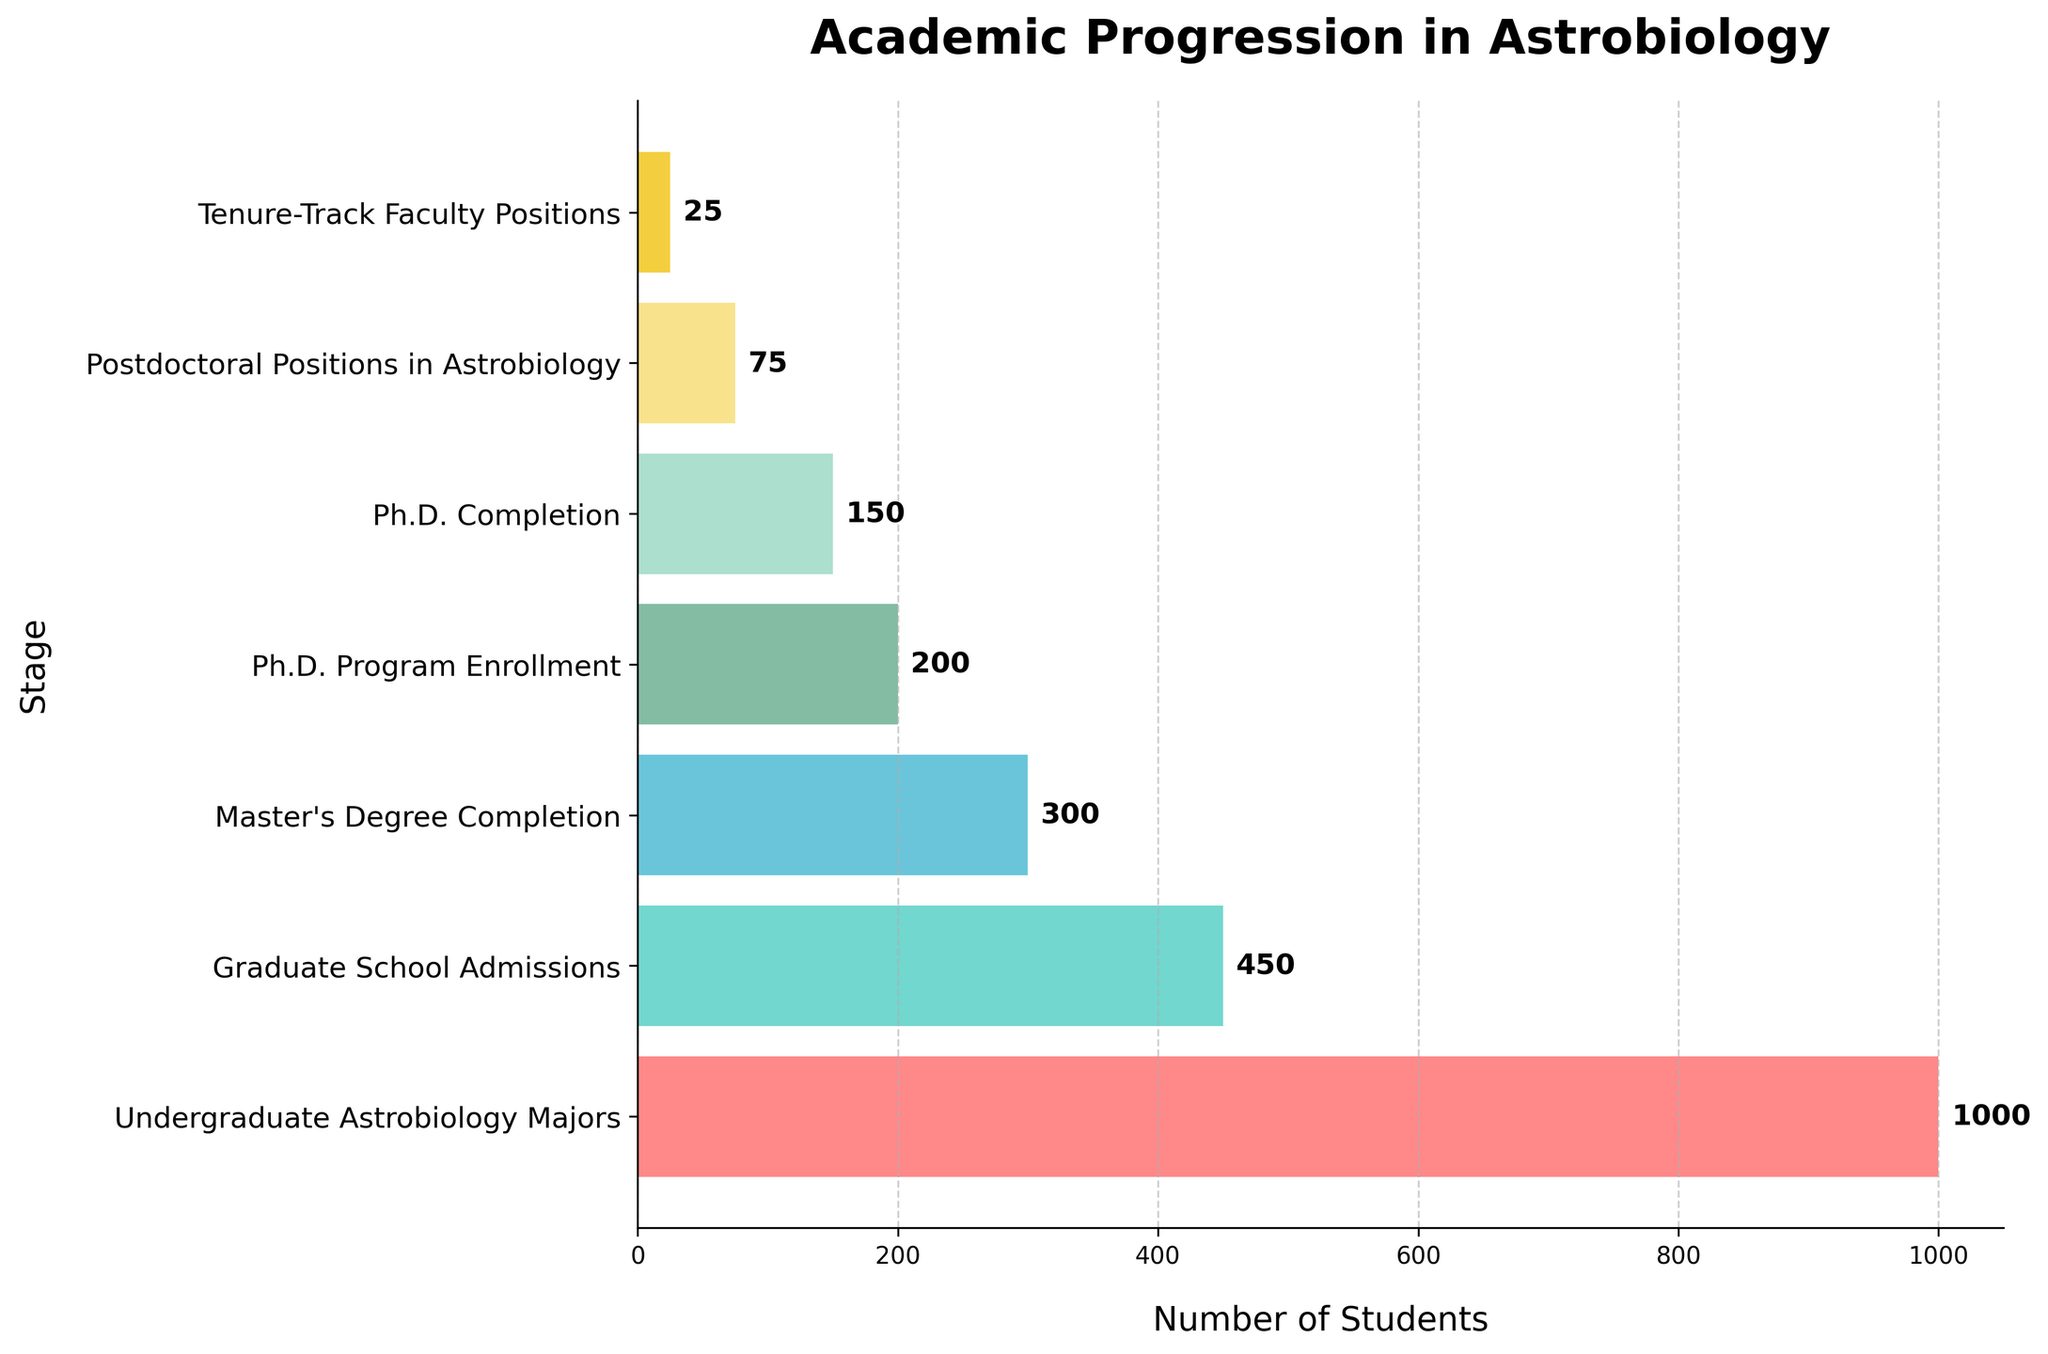What is the title of this chart? The title of the chart is typically placed at the top. In this case, it reads "Academic Progression in Astrobiology".
Answer: Academic Progression in Astrobiology How many stages are represented in this funnel chart? The funnel chart has labels for each stage on the y-axis. By counting these labels, we can see that there are seven stages.
Answer: Seven Which stage has the highest number of students? By looking at the width of the bars on the funnel chart, the widest bar represents the stage with the highest number of students. The label for the widest bar is "Undergraduate Astrobiology Majors".
Answer: Undergraduate Astrobiology Majors What is the number of students who complete their Ph.D. in Astrobiology? We can identify the width of the bar labeled "Ph.D. Completion" on the y-axis, and the number indicated is 150.
Answer: 150 How many students transition from Master's Degree Completion to Ph.D. Program Enrollment? To find the number of students transitioning between these stages, we look at the difference between "Master's Degree Completion" and "Ph.D. Program Enrollment". "Master's Degree Completion" has 300 students and "Ph.D. Program Enrollment" has 200 students. Subtracting these gives the number of students transitioning as 300 - 200 = 100.
Answer: 100 How many more students are admitted to graduate school than those who eventually secure tenure-track faculty positions? The number of students admitted to graduate school is 450, and the number of tenure-track faculty positions is 25. The difference, 450 - 25, gives us 425.
Answer: 425 What percentage of students who begin as undergraduate astrobiology majors eventually complete a Ph.D.? Starting with 1000 undergraduate majors and noting that 150 complete a Ph.D., the percentage is calculated as (150 / 1000) * 100 = 15%.
Answer: 15% Of the students who begin their Ph.D. program, how many do not complete it? By comparing the number of students who enroll in the Ph.D. program (200) to those who complete it (150), we find the number who do not complete it as 200 - 150 = 50.
Answer: 50 What is the retention rate from Ph.D. Completion to Postdoctoral Positions in Astrobiology? With 150 students completing their Ph.D. and 75 securing postdoctoral positions, the retention rate is (75 / 150) * 100 = 50%.
Answer: 50% Which stage has precisely double the number of students compared to another stage? By examining the data points, "Master's Degree Completion" has 300 students, which is double the number of students in the "Postdoctoral Positions in Astrobiology" stage, which has 75 students.
Answer: Master's Degree Completion and Postdoctoral Positions in Astrobiology 